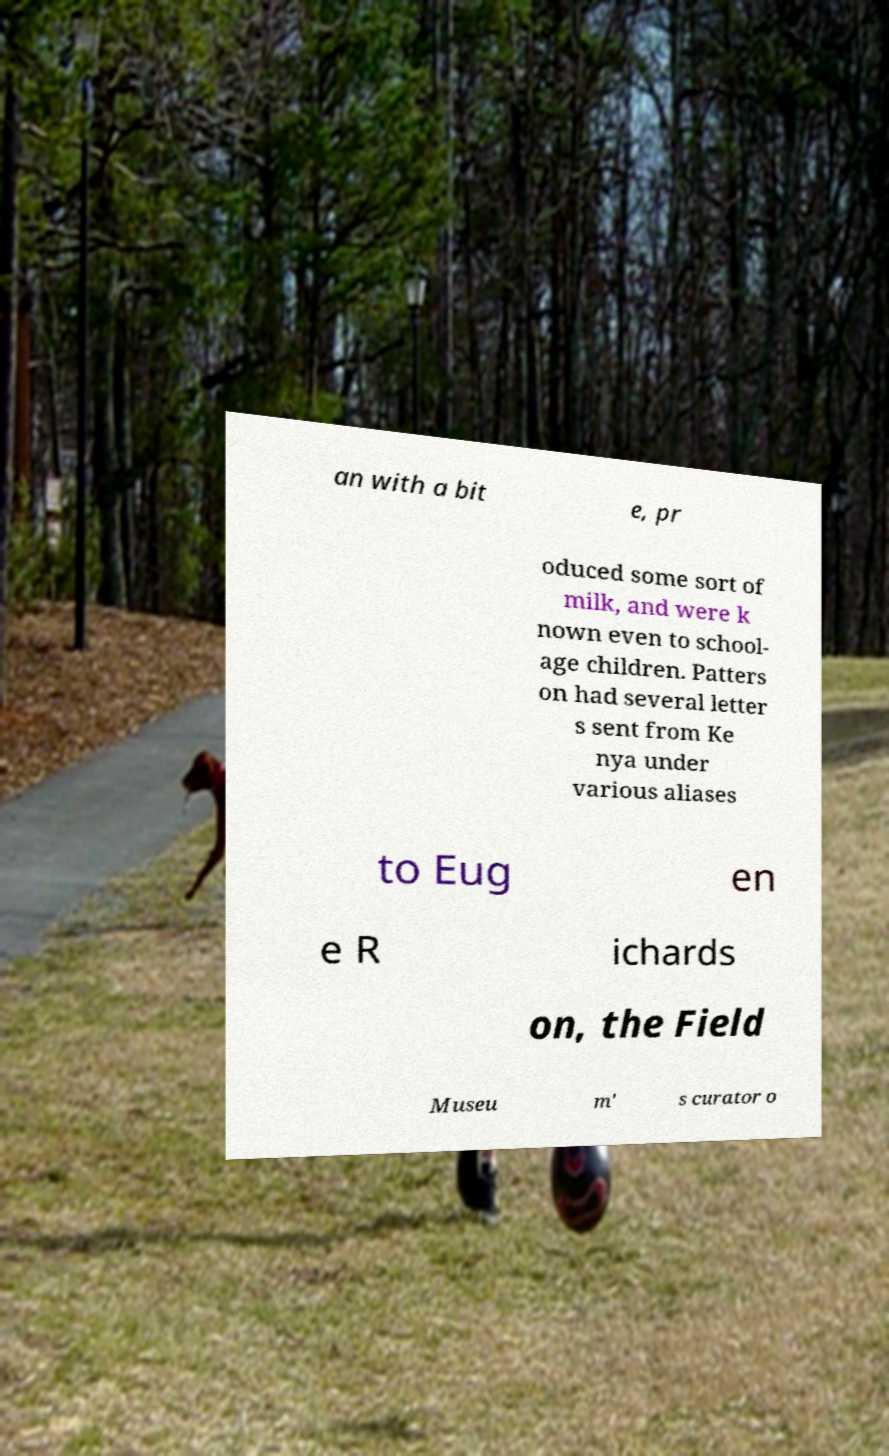Could you extract and type out the text from this image? an with a bit e, pr oduced some sort of milk, and were k nown even to school- age children. Patters on had several letter s sent from Ke nya under various aliases to Eug en e R ichards on, the Field Museu m' s curator o 